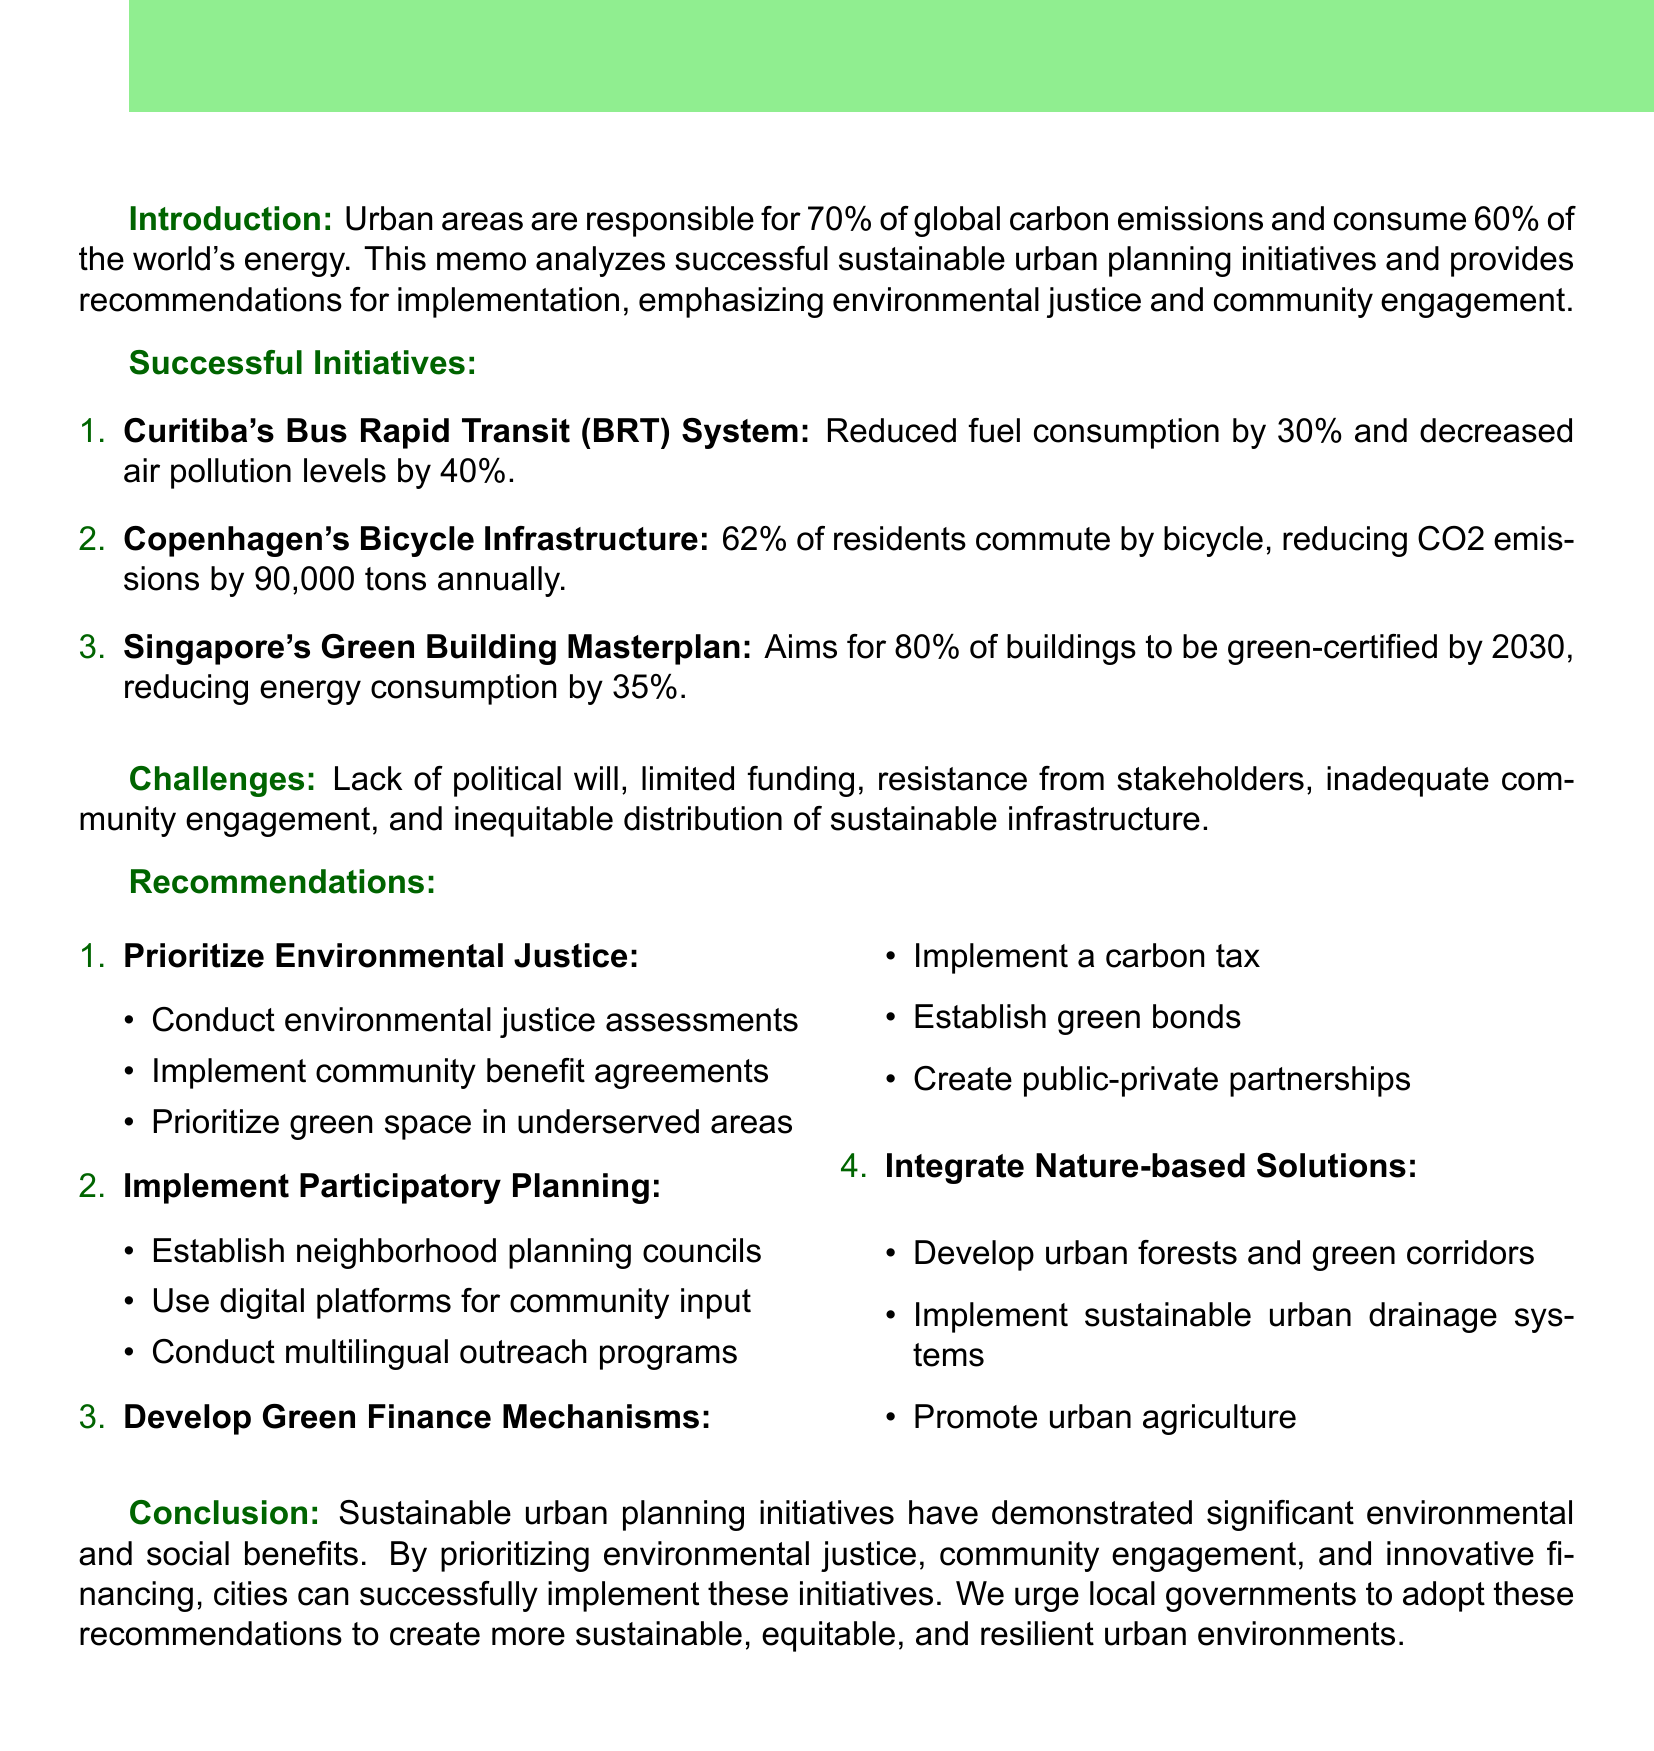what percentage of global carbon emissions come from urban areas? Urban areas are responsible for 70% of global carbon emissions as noted in the introduction.
Answer: 70% what is a key feature of Curitiba's Bus Rapid Transit System? The document lists several key features of the initiative, one of which is dedicated bus lanes.
Answer: Dedicated bus lanes what is the environmental impact of Copenhagen's Bicycle Infrastructure? The memo states that this initiative results in a reduction of CO2 emissions by 90,000 tons annually.
Answer: 90,000 tons what strategy aims for 80% of buildings to be green-certified by 2030? This is described in the section about Singapore's Green Building Masterplan.
Answer: Singapore's Green Building Masterplan what challenge is related to community participation in sustainable urban planning? The document mentions inadequate community engagement and participation as a challenge.
Answer: Inadequate community engagement what is one recommendation made in the memo regarding planning? One recommendation is to prioritize environmental justice in planning.
Answer: Prioritize environmental justice how many kilometers of dedicated cycle tracks are in Copenhagen? It is stated that there are 350 km of dedicated cycle tracks in Copenhagen's Bicycle Infrastructure.
Answer: 350 km what is one proposed method for innovative funding sources? The memo proposes implementing a carbon tax as a method for funding.
Answer: Implement a carbon tax what is the call to action mentioned in the conclusion? The conclusion urges local governments to adopt and implement the recommendations.
Answer: Urge local governments to adopt and implement these recommendations 